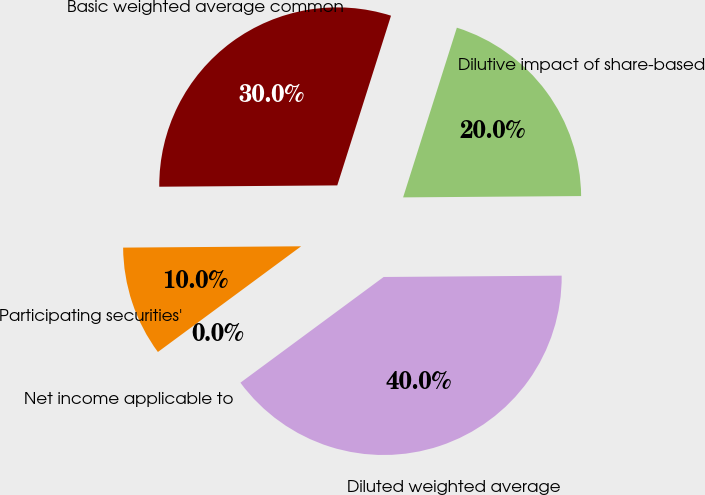<chart> <loc_0><loc_0><loc_500><loc_500><pie_chart><fcel>Net income applicable to<fcel>Participating securities'<fcel>Basic weighted average common<fcel>Dilutive impact of share-based<fcel>Diluted weighted average<nl><fcel>0.0%<fcel>10.0%<fcel>30.0%<fcel>20.0%<fcel>40.0%<nl></chart> 